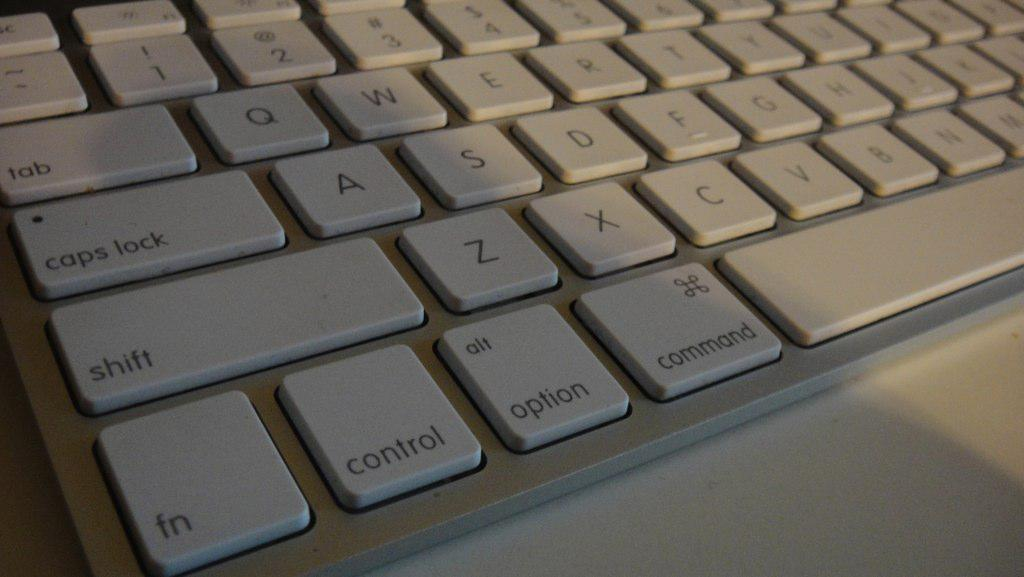<image>
Give a short and clear explanation of the subsequent image. A keyboard for a MAC as the bottom by the command key is shown. 